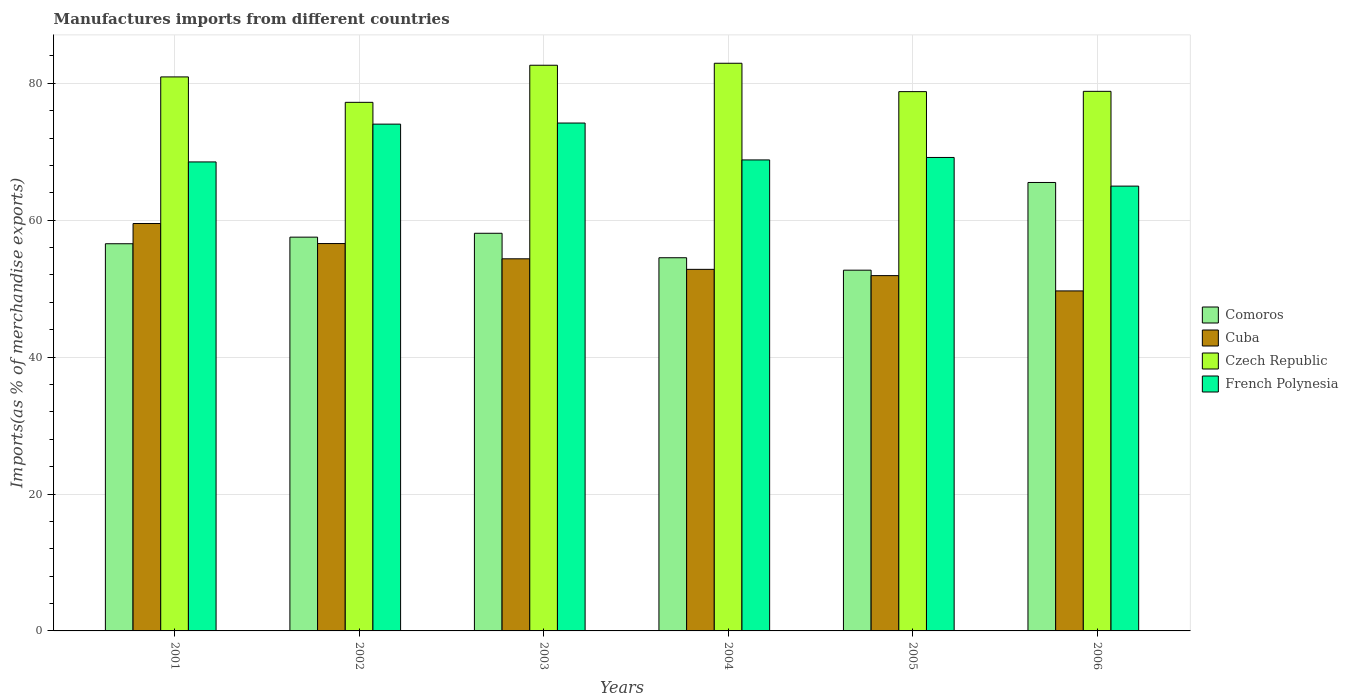How many bars are there on the 5th tick from the right?
Give a very brief answer. 4. What is the label of the 3rd group of bars from the left?
Give a very brief answer. 2003. In how many cases, is the number of bars for a given year not equal to the number of legend labels?
Offer a terse response. 0. What is the percentage of imports to different countries in Comoros in 2003?
Give a very brief answer. 58.09. Across all years, what is the maximum percentage of imports to different countries in Czech Republic?
Make the answer very short. 82.93. Across all years, what is the minimum percentage of imports to different countries in French Polynesia?
Your answer should be compact. 64.98. What is the total percentage of imports to different countries in Comoros in the graph?
Your answer should be compact. 344.9. What is the difference between the percentage of imports to different countries in Czech Republic in 2003 and that in 2004?
Make the answer very short. -0.29. What is the difference between the percentage of imports to different countries in Cuba in 2002 and the percentage of imports to different countries in Czech Republic in 2004?
Give a very brief answer. -26.34. What is the average percentage of imports to different countries in Comoros per year?
Your answer should be very brief. 57.48. In the year 2004, what is the difference between the percentage of imports to different countries in Czech Republic and percentage of imports to different countries in Comoros?
Your response must be concise. 28.41. What is the ratio of the percentage of imports to different countries in Czech Republic in 2002 to that in 2005?
Offer a terse response. 0.98. Is the difference between the percentage of imports to different countries in Czech Republic in 2001 and 2006 greater than the difference between the percentage of imports to different countries in Comoros in 2001 and 2006?
Your answer should be very brief. Yes. What is the difference between the highest and the second highest percentage of imports to different countries in Czech Republic?
Offer a very short reply. 0.29. What is the difference between the highest and the lowest percentage of imports to different countries in Czech Republic?
Offer a terse response. 5.71. In how many years, is the percentage of imports to different countries in Czech Republic greater than the average percentage of imports to different countries in Czech Republic taken over all years?
Offer a very short reply. 3. Is it the case that in every year, the sum of the percentage of imports to different countries in Comoros and percentage of imports to different countries in Cuba is greater than the sum of percentage of imports to different countries in Czech Republic and percentage of imports to different countries in French Polynesia?
Provide a short and direct response. No. What does the 4th bar from the left in 2003 represents?
Provide a succinct answer. French Polynesia. What does the 2nd bar from the right in 2006 represents?
Give a very brief answer. Czech Republic. How many bars are there?
Give a very brief answer. 24. What is the difference between two consecutive major ticks on the Y-axis?
Your answer should be very brief. 20. Are the values on the major ticks of Y-axis written in scientific E-notation?
Provide a short and direct response. No. Does the graph contain grids?
Ensure brevity in your answer.  Yes. How many legend labels are there?
Your response must be concise. 4. What is the title of the graph?
Your answer should be very brief. Manufactures imports from different countries. Does "Mexico" appear as one of the legend labels in the graph?
Offer a terse response. No. What is the label or title of the X-axis?
Ensure brevity in your answer.  Years. What is the label or title of the Y-axis?
Ensure brevity in your answer.  Imports(as % of merchandise exports). What is the Imports(as % of merchandise exports) in Comoros in 2001?
Your answer should be very brief. 56.56. What is the Imports(as % of merchandise exports) in Cuba in 2001?
Give a very brief answer. 59.51. What is the Imports(as % of merchandise exports) in Czech Republic in 2001?
Provide a succinct answer. 80.93. What is the Imports(as % of merchandise exports) in French Polynesia in 2001?
Provide a short and direct response. 68.51. What is the Imports(as % of merchandise exports) of Comoros in 2002?
Your answer should be very brief. 57.52. What is the Imports(as % of merchandise exports) of Cuba in 2002?
Provide a succinct answer. 56.59. What is the Imports(as % of merchandise exports) of Czech Republic in 2002?
Offer a very short reply. 77.22. What is the Imports(as % of merchandise exports) in French Polynesia in 2002?
Make the answer very short. 74.03. What is the Imports(as % of merchandise exports) in Comoros in 2003?
Offer a terse response. 58.09. What is the Imports(as % of merchandise exports) of Cuba in 2003?
Make the answer very short. 54.36. What is the Imports(as % of merchandise exports) in Czech Republic in 2003?
Make the answer very short. 82.64. What is the Imports(as % of merchandise exports) in French Polynesia in 2003?
Your answer should be very brief. 74.19. What is the Imports(as % of merchandise exports) in Comoros in 2004?
Your response must be concise. 54.52. What is the Imports(as % of merchandise exports) in Cuba in 2004?
Offer a very short reply. 52.82. What is the Imports(as % of merchandise exports) of Czech Republic in 2004?
Give a very brief answer. 82.93. What is the Imports(as % of merchandise exports) in French Polynesia in 2004?
Keep it short and to the point. 68.8. What is the Imports(as % of merchandise exports) of Comoros in 2005?
Ensure brevity in your answer.  52.7. What is the Imports(as % of merchandise exports) in Cuba in 2005?
Your answer should be very brief. 51.9. What is the Imports(as % of merchandise exports) in Czech Republic in 2005?
Your answer should be compact. 78.78. What is the Imports(as % of merchandise exports) of French Polynesia in 2005?
Your answer should be compact. 69.17. What is the Imports(as % of merchandise exports) in Comoros in 2006?
Keep it short and to the point. 65.51. What is the Imports(as % of merchandise exports) of Cuba in 2006?
Give a very brief answer. 49.67. What is the Imports(as % of merchandise exports) of Czech Republic in 2006?
Your answer should be compact. 78.82. What is the Imports(as % of merchandise exports) of French Polynesia in 2006?
Your answer should be compact. 64.98. Across all years, what is the maximum Imports(as % of merchandise exports) in Comoros?
Offer a terse response. 65.51. Across all years, what is the maximum Imports(as % of merchandise exports) in Cuba?
Your response must be concise. 59.51. Across all years, what is the maximum Imports(as % of merchandise exports) of Czech Republic?
Give a very brief answer. 82.93. Across all years, what is the maximum Imports(as % of merchandise exports) of French Polynesia?
Your answer should be compact. 74.19. Across all years, what is the minimum Imports(as % of merchandise exports) in Comoros?
Keep it short and to the point. 52.7. Across all years, what is the minimum Imports(as % of merchandise exports) of Cuba?
Make the answer very short. 49.67. Across all years, what is the minimum Imports(as % of merchandise exports) in Czech Republic?
Your answer should be compact. 77.22. Across all years, what is the minimum Imports(as % of merchandise exports) in French Polynesia?
Your answer should be very brief. 64.98. What is the total Imports(as % of merchandise exports) of Comoros in the graph?
Your answer should be very brief. 344.9. What is the total Imports(as % of merchandise exports) of Cuba in the graph?
Give a very brief answer. 324.86. What is the total Imports(as % of merchandise exports) of Czech Republic in the graph?
Offer a very short reply. 481.32. What is the total Imports(as % of merchandise exports) in French Polynesia in the graph?
Your response must be concise. 419.69. What is the difference between the Imports(as % of merchandise exports) of Comoros in 2001 and that in 2002?
Make the answer very short. -0.96. What is the difference between the Imports(as % of merchandise exports) in Cuba in 2001 and that in 2002?
Offer a very short reply. 2.93. What is the difference between the Imports(as % of merchandise exports) of Czech Republic in 2001 and that in 2002?
Your answer should be compact. 3.71. What is the difference between the Imports(as % of merchandise exports) of French Polynesia in 2001 and that in 2002?
Keep it short and to the point. -5.52. What is the difference between the Imports(as % of merchandise exports) in Comoros in 2001 and that in 2003?
Your answer should be very brief. -1.53. What is the difference between the Imports(as % of merchandise exports) in Cuba in 2001 and that in 2003?
Keep it short and to the point. 5.15. What is the difference between the Imports(as % of merchandise exports) in Czech Republic in 2001 and that in 2003?
Your response must be concise. -1.71. What is the difference between the Imports(as % of merchandise exports) in French Polynesia in 2001 and that in 2003?
Provide a short and direct response. -5.68. What is the difference between the Imports(as % of merchandise exports) of Comoros in 2001 and that in 2004?
Your response must be concise. 2.05. What is the difference between the Imports(as % of merchandise exports) in Cuba in 2001 and that in 2004?
Your response must be concise. 6.69. What is the difference between the Imports(as % of merchandise exports) of Czech Republic in 2001 and that in 2004?
Give a very brief answer. -1.99. What is the difference between the Imports(as % of merchandise exports) in French Polynesia in 2001 and that in 2004?
Give a very brief answer. -0.29. What is the difference between the Imports(as % of merchandise exports) in Comoros in 2001 and that in 2005?
Provide a succinct answer. 3.86. What is the difference between the Imports(as % of merchandise exports) in Cuba in 2001 and that in 2005?
Ensure brevity in your answer.  7.61. What is the difference between the Imports(as % of merchandise exports) in Czech Republic in 2001 and that in 2005?
Keep it short and to the point. 2.15. What is the difference between the Imports(as % of merchandise exports) of French Polynesia in 2001 and that in 2005?
Give a very brief answer. -0.65. What is the difference between the Imports(as % of merchandise exports) of Comoros in 2001 and that in 2006?
Your response must be concise. -8.95. What is the difference between the Imports(as % of merchandise exports) of Cuba in 2001 and that in 2006?
Keep it short and to the point. 9.84. What is the difference between the Imports(as % of merchandise exports) in Czech Republic in 2001 and that in 2006?
Offer a terse response. 2.11. What is the difference between the Imports(as % of merchandise exports) of French Polynesia in 2001 and that in 2006?
Ensure brevity in your answer.  3.53. What is the difference between the Imports(as % of merchandise exports) of Comoros in 2002 and that in 2003?
Keep it short and to the point. -0.56. What is the difference between the Imports(as % of merchandise exports) in Cuba in 2002 and that in 2003?
Offer a terse response. 2.23. What is the difference between the Imports(as % of merchandise exports) in Czech Republic in 2002 and that in 2003?
Ensure brevity in your answer.  -5.42. What is the difference between the Imports(as % of merchandise exports) of French Polynesia in 2002 and that in 2003?
Ensure brevity in your answer.  -0.16. What is the difference between the Imports(as % of merchandise exports) in Comoros in 2002 and that in 2004?
Ensure brevity in your answer.  3.01. What is the difference between the Imports(as % of merchandise exports) in Cuba in 2002 and that in 2004?
Make the answer very short. 3.77. What is the difference between the Imports(as % of merchandise exports) of Czech Republic in 2002 and that in 2004?
Provide a short and direct response. -5.71. What is the difference between the Imports(as % of merchandise exports) in French Polynesia in 2002 and that in 2004?
Your answer should be very brief. 5.23. What is the difference between the Imports(as % of merchandise exports) of Comoros in 2002 and that in 2005?
Offer a terse response. 4.83. What is the difference between the Imports(as % of merchandise exports) in Cuba in 2002 and that in 2005?
Keep it short and to the point. 4.68. What is the difference between the Imports(as % of merchandise exports) of Czech Republic in 2002 and that in 2005?
Your response must be concise. -1.56. What is the difference between the Imports(as % of merchandise exports) of French Polynesia in 2002 and that in 2005?
Ensure brevity in your answer.  4.87. What is the difference between the Imports(as % of merchandise exports) in Comoros in 2002 and that in 2006?
Your answer should be very brief. -7.99. What is the difference between the Imports(as % of merchandise exports) of Cuba in 2002 and that in 2006?
Your answer should be very brief. 6.92. What is the difference between the Imports(as % of merchandise exports) of Czech Republic in 2002 and that in 2006?
Make the answer very short. -1.61. What is the difference between the Imports(as % of merchandise exports) of French Polynesia in 2002 and that in 2006?
Keep it short and to the point. 9.06. What is the difference between the Imports(as % of merchandise exports) of Comoros in 2003 and that in 2004?
Keep it short and to the point. 3.57. What is the difference between the Imports(as % of merchandise exports) in Cuba in 2003 and that in 2004?
Make the answer very short. 1.54. What is the difference between the Imports(as % of merchandise exports) of Czech Republic in 2003 and that in 2004?
Ensure brevity in your answer.  -0.29. What is the difference between the Imports(as % of merchandise exports) of French Polynesia in 2003 and that in 2004?
Provide a short and direct response. 5.39. What is the difference between the Imports(as % of merchandise exports) in Comoros in 2003 and that in 2005?
Provide a succinct answer. 5.39. What is the difference between the Imports(as % of merchandise exports) in Cuba in 2003 and that in 2005?
Provide a succinct answer. 2.46. What is the difference between the Imports(as % of merchandise exports) in Czech Republic in 2003 and that in 2005?
Keep it short and to the point. 3.86. What is the difference between the Imports(as % of merchandise exports) in French Polynesia in 2003 and that in 2005?
Keep it short and to the point. 5.03. What is the difference between the Imports(as % of merchandise exports) in Comoros in 2003 and that in 2006?
Provide a short and direct response. -7.42. What is the difference between the Imports(as % of merchandise exports) of Cuba in 2003 and that in 2006?
Offer a terse response. 4.69. What is the difference between the Imports(as % of merchandise exports) in Czech Republic in 2003 and that in 2006?
Ensure brevity in your answer.  3.81. What is the difference between the Imports(as % of merchandise exports) of French Polynesia in 2003 and that in 2006?
Ensure brevity in your answer.  9.21. What is the difference between the Imports(as % of merchandise exports) of Comoros in 2004 and that in 2005?
Your answer should be compact. 1.82. What is the difference between the Imports(as % of merchandise exports) of Cuba in 2004 and that in 2005?
Ensure brevity in your answer.  0.92. What is the difference between the Imports(as % of merchandise exports) of Czech Republic in 2004 and that in 2005?
Your answer should be compact. 4.14. What is the difference between the Imports(as % of merchandise exports) in French Polynesia in 2004 and that in 2005?
Your answer should be very brief. -0.36. What is the difference between the Imports(as % of merchandise exports) in Comoros in 2004 and that in 2006?
Your answer should be very brief. -10.99. What is the difference between the Imports(as % of merchandise exports) in Cuba in 2004 and that in 2006?
Ensure brevity in your answer.  3.15. What is the difference between the Imports(as % of merchandise exports) of Czech Republic in 2004 and that in 2006?
Your answer should be compact. 4.1. What is the difference between the Imports(as % of merchandise exports) in French Polynesia in 2004 and that in 2006?
Keep it short and to the point. 3.83. What is the difference between the Imports(as % of merchandise exports) of Comoros in 2005 and that in 2006?
Keep it short and to the point. -12.81. What is the difference between the Imports(as % of merchandise exports) of Cuba in 2005 and that in 2006?
Offer a terse response. 2.23. What is the difference between the Imports(as % of merchandise exports) of Czech Republic in 2005 and that in 2006?
Give a very brief answer. -0.04. What is the difference between the Imports(as % of merchandise exports) of French Polynesia in 2005 and that in 2006?
Provide a succinct answer. 4.19. What is the difference between the Imports(as % of merchandise exports) in Comoros in 2001 and the Imports(as % of merchandise exports) in Cuba in 2002?
Your answer should be compact. -0.03. What is the difference between the Imports(as % of merchandise exports) of Comoros in 2001 and the Imports(as % of merchandise exports) of Czech Republic in 2002?
Offer a terse response. -20.66. What is the difference between the Imports(as % of merchandise exports) of Comoros in 2001 and the Imports(as % of merchandise exports) of French Polynesia in 2002?
Offer a terse response. -17.47. What is the difference between the Imports(as % of merchandise exports) in Cuba in 2001 and the Imports(as % of merchandise exports) in Czech Republic in 2002?
Ensure brevity in your answer.  -17.7. What is the difference between the Imports(as % of merchandise exports) in Cuba in 2001 and the Imports(as % of merchandise exports) in French Polynesia in 2002?
Give a very brief answer. -14.52. What is the difference between the Imports(as % of merchandise exports) of Czech Republic in 2001 and the Imports(as % of merchandise exports) of French Polynesia in 2002?
Offer a terse response. 6.9. What is the difference between the Imports(as % of merchandise exports) in Comoros in 2001 and the Imports(as % of merchandise exports) in Cuba in 2003?
Offer a very short reply. 2.2. What is the difference between the Imports(as % of merchandise exports) of Comoros in 2001 and the Imports(as % of merchandise exports) of Czech Republic in 2003?
Provide a succinct answer. -26.08. What is the difference between the Imports(as % of merchandise exports) in Comoros in 2001 and the Imports(as % of merchandise exports) in French Polynesia in 2003?
Ensure brevity in your answer.  -17.63. What is the difference between the Imports(as % of merchandise exports) in Cuba in 2001 and the Imports(as % of merchandise exports) in Czech Republic in 2003?
Ensure brevity in your answer.  -23.12. What is the difference between the Imports(as % of merchandise exports) in Cuba in 2001 and the Imports(as % of merchandise exports) in French Polynesia in 2003?
Your answer should be very brief. -14.68. What is the difference between the Imports(as % of merchandise exports) of Czech Republic in 2001 and the Imports(as % of merchandise exports) of French Polynesia in 2003?
Provide a short and direct response. 6.74. What is the difference between the Imports(as % of merchandise exports) in Comoros in 2001 and the Imports(as % of merchandise exports) in Cuba in 2004?
Offer a terse response. 3.74. What is the difference between the Imports(as % of merchandise exports) in Comoros in 2001 and the Imports(as % of merchandise exports) in Czech Republic in 2004?
Give a very brief answer. -26.37. What is the difference between the Imports(as % of merchandise exports) in Comoros in 2001 and the Imports(as % of merchandise exports) in French Polynesia in 2004?
Make the answer very short. -12.24. What is the difference between the Imports(as % of merchandise exports) in Cuba in 2001 and the Imports(as % of merchandise exports) in Czech Republic in 2004?
Make the answer very short. -23.41. What is the difference between the Imports(as % of merchandise exports) of Cuba in 2001 and the Imports(as % of merchandise exports) of French Polynesia in 2004?
Ensure brevity in your answer.  -9.29. What is the difference between the Imports(as % of merchandise exports) of Czech Republic in 2001 and the Imports(as % of merchandise exports) of French Polynesia in 2004?
Your answer should be compact. 12.13. What is the difference between the Imports(as % of merchandise exports) in Comoros in 2001 and the Imports(as % of merchandise exports) in Cuba in 2005?
Provide a short and direct response. 4.66. What is the difference between the Imports(as % of merchandise exports) in Comoros in 2001 and the Imports(as % of merchandise exports) in Czech Republic in 2005?
Your response must be concise. -22.22. What is the difference between the Imports(as % of merchandise exports) in Comoros in 2001 and the Imports(as % of merchandise exports) in French Polynesia in 2005?
Offer a very short reply. -12.61. What is the difference between the Imports(as % of merchandise exports) in Cuba in 2001 and the Imports(as % of merchandise exports) in Czech Republic in 2005?
Offer a very short reply. -19.27. What is the difference between the Imports(as % of merchandise exports) in Cuba in 2001 and the Imports(as % of merchandise exports) in French Polynesia in 2005?
Your answer should be very brief. -9.65. What is the difference between the Imports(as % of merchandise exports) of Czech Republic in 2001 and the Imports(as % of merchandise exports) of French Polynesia in 2005?
Your answer should be compact. 11.77. What is the difference between the Imports(as % of merchandise exports) of Comoros in 2001 and the Imports(as % of merchandise exports) of Cuba in 2006?
Offer a terse response. 6.89. What is the difference between the Imports(as % of merchandise exports) in Comoros in 2001 and the Imports(as % of merchandise exports) in Czech Republic in 2006?
Provide a short and direct response. -22.26. What is the difference between the Imports(as % of merchandise exports) of Comoros in 2001 and the Imports(as % of merchandise exports) of French Polynesia in 2006?
Keep it short and to the point. -8.42. What is the difference between the Imports(as % of merchandise exports) in Cuba in 2001 and the Imports(as % of merchandise exports) in Czech Republic in 2006?
Keep it short and to the point. -19.31. What is the difference between the Imports(as % of merchandise exports) in Cuba in 2001 and the Imports(as % of merchandise exports) in French Polynesia in 2006?
Make the answer very short. -5.46. What is the difference between the Imports(as % of merchandise exports) of Czech Republic in 2001 and the Imports(as % of merchandise exports) of French Polynesia in 2006?
Provide a succinct answer. 15.95. What is the difference between the Imports(as % of merchandise exports) of Comoros in 2002 and the Imports(as % of merchandise exports) of Cuba in 2003?
Your answer should be compact. 3.16. What is the difference between the Imports(as % of merchandise exports) in Comoros in 2002 and the Imports(as % of merchandise exports) in Czech Republic in 2003?
Provide a short and direct response. -25.11. What is the difference between the Imports(as % of merchandise exports) in Comoros in 2002 and the Imports(as % of merchandise exports) in French Polynesia in 2003?
Keep it short and to the point. -16.67. What is the difference between the Imports(as % of merchandise exports) in Cuba in 2002 and the Imports(as % of merchandise exports) in Czech Republic in 2003?
Offer a terse response. -26.05. What is the difference between the Imports(as % of merchandise exports) of Cuba in 2002 and the Imports(as % of merchandise exports) of French Polynesia in 2003?
Make the answer very short. -17.6. What is the difference between the Imports(as % of merchandise exports) of Czech Republic in 2002 and the Imports(as % of merchandise exports) of French Polynesia in 2003?
Provide a succinct answer. 3.02. What is the difference between the Imports(as % of merchandise exports) in Comoros in 2002 and the Imports(as % of merchandise exports) in Cuba in 2004?
Offer a very short reply. 4.7. What is the difference between the Imports(as % of merchandise exports) of Comoros in 2002 and the Imports(as % of merchandise exports) of Czech Republic in 2004?
Provide a succinct answer. -25.4. What is the difference between the Imports(as % of merchandise exports) of Comoros in 2002 and the Imports(as % of merchandise exports) of French Polynesia in 2004?
Provide a succinct answer. -11.28. What is the difference between the Imports(as % of merchandise exports) of Cuba in 2002 and the Imports(as % of merchandise exports) of Czech Republic in 2004?
Ensure brevity in your answer.  -26.34. What is the difference between the Imports(as % of merchandise exports) in Cuba in 2002 and the Imports(as % of merchandise exports) in French Polynesia in 2004?
Provide a succinct answer. -12.22. What is the difference between the Imports(as % of merchandise exports) in Czech Republic in 2002 and the Imports(as % of merchandise exports) in French Polynesia in 2004?
Offer a terse response. 8.41. What is the difference between the Imports(as % of merchandise exports) in Comoros in 2002 and the Imports(as % of merchandise exports) in Cuba in 2005?
Offer a terse response. 5.62. What is the difference between the Imports(as % of merchandise exports) in Comoros in 2002 and the Imports(as % of merchandise exports) in Czech Republic in 2005?
Give a very brief answer. -21.26. What is the difference between the Imports(as % of merchandise exports) of Comoros in 2002 and the Imports(as % of merchandise exports) of French Polynesia in 2005?
Make the answer very short. -11.64. What is the difference between the Imports(as % of merchandise exports) in Cuba in 2002 and the Imports(as % of merchandise exports) in Czech Republic in 2005?
Make the answer very short. -22.19. What is the difference between the Imports(as % of merchandise exports) in Cuba in 2002 and the Imports(as % of merchandise exports) in French Polynesia in 2005?
Your answer should be compact. -12.58. What is the difference between the Imports(as % of merchandise exports) in Czech Republic in 2002 and the Imports(as % of merchandise exports) in French Polynesia in 2005?
Make the answer very short. 8.05. What is the difference between the Imports(as % of merchandise exports) in Comoros in 2002 and the Imports(as % of merchandise exports) in Cuba in 2006?
Ensure brevity in your answer.  7.85. What is the difference between the Imports(as % of merchandise exports) of Comoros in 2002 and the Imports(as % of merchandise exports) of Czech Republic in 2006?
Your answer should be compact. -21.3. What is the difference between the Imports(as % of merchandise exports) of Comoros in 2002 and the Imports(as % of merchandise exports) of French Polynesia in 2006?
Your answer should be compact. -7.45. What is the difference between the Imports(as % of merchandise exports) in Cuba in 2002 and the Imports(as % of merchandise exports) in Czech Republic in 2006?
Your response must be concise. -22.24. What is the difference between the Imports(as % of merchandise exports) in Cuba in 2002 and the Imports(as % of merchandise exports) in French Polynesia in 2006?
Your response must be concise. -8.39. What is the difference between the Imports(as % of merchandise exports) in Czech Republic in 2002 and the Imports(as % of merchandise exports) in French Polynesia in 2006?
Your answer should be compact. 12.24. What is the difference between the Imports(as % of merchandise exports) of Comoros in 2003 and the Imports(as % of merchandise exports) of Cuba in 2004?
Keep it short and to the point. 5.27. What is the difference between the Imports(as % of merchandise exports) of Comoros in 2003 and the Imports(as % of merchandise exports) of Czech Republic in 2004?
Provide a short and direct response. -24.84. What is the difference between the Imports(as % of merchandise exports) in Comoros in 2003 and the Imports(as % of merchandise exports) in French Polynesia in 2004?
Your answer should be very brief. -10.72. What is the difference between the Imports(as % of merchandise exports) in Cuba in 2003 and the Imports(as % of merchandise exports) in Czech Republic in 2004?
Give a very brief answer. -28.57. What is the difference between the Imports(as % of merchandise exports) of Cuba in 2003 and the Imports(as % of merchandise exports) of French Polynesia in 2004?
Provide a short and direct response. -14.44. What is the difference between the Imports(as % of merchandise exports) of Czech Republic in 2003 and the Imports(as % of merchandise exports) of French Polynesia in 2004?
Make the answer very short. 13.83. What is the difference between the Imports(as % of merchandise exports) of Comoros in 2003 and the Imports(as % of merchandise exports) of Cuba in 2005?
Offer a very short reply. 6.18. What is the difference between the Imports(as % of merchandise exports) in Comoros in 2003 and the Imports(as % of merchandise exports) in Czech Republic in 2005?
Make the answer very short. -20.69. What is the difference between the Imports(as % of merchandise exports) in Comoros in 2003 and the Imports(as % of merchandise exports) in French Polynesia in 2005?
Provide a short and direct response. -11.08. What is the difference between the Imports(as % of merchandise exports) of Cuba in 2003 and the Imports(as % of merchandise exports) of Czech Republic in 2005?
Make the answer very short. -24.42. What is the difference between the Imports(as % of merchandise exports) of Cuba in 2003 and the Imports(as % of merchandise exports) of French Polynesia in 2005?
Your answer should be very brief. -14.81. What is the difference between the Imports(as % of merchandise exports) of Czech Republic in 2003 and the Imports(as % of merchandise exports) of French Polynesia in 2005?
Your answer should be compact. 13.47. What is the difference between the Imports(as % of merchandise exports) in Comoros in 2003 and the Imports(as % of merchandise exports) in Cuba in 2006?
Provide a short and direct response. 8.42. What is the difference between the Imports(as % of merchandise exports) in Comoros in 2003 and the Imports(as % of merchandise exports) in Czech Republic in 2006?
Give a very brief answer. -20.73. What is the difference between the Imports(as % of merchandise exports) in Comoros in 2003 and the Imports(as % of merchandise exports) in French Polynesia in 2006?
Your answer should be compact. -6.89. What is the difference between the Imports(as % of merchandise exports) of Cuba in 2003 and the Imports(as % of merchandise exports) of Czech Republic in 2006?
Offer a very short reply. -24.46. What is the difference between the Imports(as % of merchandise exports) in Cuba in 2003 and the Imports(as % of merchandise exports) in French Polynesia in 2006?
Offer a very short reply. -10.62. What is the difference between the Imports(as % of merchandise exports) in Czech Republic in 2003 and the Imports(as % of merchandise exports) in French Polynesia in 2006?
Make the answer very short. 17.66. What is the difference between the Imports(as % of merchandise exports) of Comoros in 2004 and the Imports(as % of merchandise exports) of Cuba in 2005?
Offer a very short reply. 2.61. What is the difference between the Imports(as % of merchandise exports) of Comoros in 2004 and the Imports(as % of merchandise exports) of Czech Republic in 2005?
Make the answer very short. -24.27. What is the difference between the Imports(as % of merchandise exports) of Comoros in 2004 and the Imports(as % of merchandise exports) of French Polynesia in 2005?
Your answer should be compact. -14.65. What is the difference between the Imports(as % of merchandise exports) of Cuba in 2004 and the Imports(as % of merchandise exports) of Czech Republic in 2005?
Your answer should be compact. -25.96. What is the difference between the Imports(as % of merchandise exports) in Cuba in 2004 and the Imports(as % of merchandise exports) in French Polynesia in 2005?
Keep it short and to the point. -16.35. What is the difference between the Imports(as % of merchandise exports) in Czech Republic in 2004 and the Imports(as % of merchandise exports) in French Polynesia in 2005?
Offer a terse response. 13.76. What is the difference between the Imports(as % of merchandise exports) of Comoros in 2004 and the Imports(as % of merchandise exports) of Cuba in 2006?
Offer a very short reply. 4.84. What is the difference between the Imports(as % of merchandise exports) in Comoros in 2004 and the Imports(as % of merchandise exports) in Czech Republic in 2006?
Your answer should be compact. -24.31. What is the difference between the Imports(as % of merchandise exports) in Comoros in 2004 and the Imports(as % of merchandise exports) in French Polynesia in 2006?
Give a very brief answer. -10.46. What is the difference between the Imports(as % of merchandise exports) in Cuba in 2004 and the Imports(as % of merchandise exports) in Czech Republic in 2006?
Keep it short and to the point. -26. What is the difference between the Imports(as % of merchandise exports) in Cuba in 2004 and the Imports(as % of merchandise exports) in French Polynesia in 2006?
Provide a succinct answer. -12.16. What is the difference between the Imports(as % of merchandise exports) of Czech Republic in 2004 and the Imports(as % of merchandise exports) of French Polynesia in 2006?
Offer a terse response. 17.95. What is the difference between the Imports(as % of merchandise exports) in Comoros in 2005 and the Imports(as % of merchandise exports) in Cuba in 2006?
Offer a very short reply. 3.03. What is the difference between the Imports(as % of merchandise exports) of Comoros in 2005 and the Imports(as % of merchandise exports) of Czech Republic in 2006?
Make the answer very short. -26.12. What is the difference between the Imports(as % of merchandise exports) of Comoros in 2005 and the Imports(as % of merchandise exports) of French Polynesia in 2006?
Your answer should be compact. -12.28. What is the difference between the Imports(as % of merchandise exports) of Cuba in 2005 and the Imports(as % of merchandise exports) of Czech Republic in 2006?
Give a very brief answer. -26.92. What is the difference between the Imports(as % of merchandise exports) of Cuba in 2005 and the Imports(as % of merchandise exports) of French Polynesia in 2006?
Ensure brevity in your answer.  -13.07. What is the difference between the Imports(as % of merchandise exports) in Czech Republic in 2005 and the Imports(as % of merchandise exports) in French Polynesia in 2006?
Provide a succinct answer. 13.8. What is the average Imports(as % of merchandise exports) of Comoros per year?
Provide a succinct answer. 57.48. What is the average Imports(as % of merchandise exports) in Cuba per year?
Your response must be concise. 54.14. What is the average Imports(as % of merchandise exports) in Czech Republic per year?
Keep it short and to the point. 80.22. What is the average Imports(as % of merchandise exports) in French Polynesia per year?
Make the answer very short. 69.95. In the year 2001, what is the difference between the Imports(as % of merchandise exports) of Comoros and Imports(as % of merchandise exports) of Cuba?
Make the answer very short. -2.95. In the year 2001, what is the difference between the Imports(as % of merchandise exports) of Comoros and Imports(as % of merchandise exports) of Czech Republic?
Offer a terse response. -24.37. In the year 2001, what is the difference between the Imports(as % of merchandise exports) of Comoros and Imports(as % of merchandise exports) of French Polynesia?
Provide a succinct answer. -11.95. In the year 2001, what is the difference between the Imports(as % of merchandise exports) of Cuba and Imports(as % of merchandise exports) of Czech Republic?
Ensure brevity in your answer.  -21.42. In the year 2001, what is the difference between the Imports(as % of merchandise exports) in Cuba and Imports(as % of merchandise exports) in French Polynesia?
Keep it short and to the point. -9. In the year 2001, what is the difference between the Imports(as % of merchandise exports) in Czech Republic and Imports(as % of merchandise exports) in French Polynesia?
Provide a succinct answer. 12.42. In the year 2002, what is the difference between the Imports(as % of merchandise exports) in Comoros and Imports(as % of merchandise exports) in Cuba?
Keep it short and to the point. 0.94. In the year 2002, what is the difference between the Imports(as % of merchandise exports) in Comoros and Imports(as % of merchandise exports) in Czech Republic?
Provide a succinct answer. -19.69. In the year 2002, what is the difference between the Imports(as % of merchandise exports) in Comoros and Imports(as % of merchandise exports) in French Polynesia?
Your answer should be compact. -16.51. In the year 2002, what is the difference between the Imports(as % of merchandise exports) in Cuba and Imports(as % of merchandise exports) in Czech Republic?
Offer a very short reply. -20.63. In the year 2002, what is the difference between the Imports(as % of merchandise exports) of Cuba and Imports(as % of merchandise exports) of French Polynesia?
Your response must be concise. -17.45. In the year 2002, what is the difference between the Imports(as % of merchandise exports) in Czech Republic and Imports(as % of merchandise exports) in French Polynesia?
Keep it short and to the point. 3.18. In the year 2003, what is the difference between the Imports(as % of merchandise exports) in Comoros and Imports(as % of merchandise exports) in Cuba?
Make the answer very short. 3.73. In the year 2003, what is the difference between the Imports(as % of merchandise exports) in Comoros and Imports(as % of merchandise exports) in Czech Republic?
Offer a terse response. -24.55. In the year 2003, what is the difference between the Imports(as % of merchandise exports) of Comoros and Imports(as % of merchandise exports) of French Polynesia?
Offer a very short reply. -16.1. In the year 2003, what is the difference between the Imports(as % of merchandise exports) in Cuba and Imports(as % of merchandise exports) in Czech Republic?
Your answer should be compact. -28.28. In the year 2003, what is the difference between the Imports(as % of merchandise exports) in Cuba and Imports(as % of merchandise exports) in French Polynesia?
Offer a terse response. -19.83. In the year 2003, what is the difference between the Imports(as % of merchandise exports) in Czech Republic and Imports(as % of merchandise exports) in French Polynesia?
Offer a very short reply. 8.44. In the year 2004, what is the difference between the Imports(as % of merchandise exports) in Comoros and Imports(as % of merchandise exports) in Cuba?
Offer a terse response. 1.7. In the year 2004, what is the difference between the Imports(as % of merchandise exports) in Comoros and Imports(as % of merchandise exports) in Czech Republic?
Ensure brevity in your answer.  -28.41. In the year 2004, what is the difference between the Imports(as % of merchandise exports) in Comoros and Imports(as % of merchandise exports) in French Polynesia?
Provide a short and direct response. -14.29. In the year 2004, what is the difference between the Imports(as % of merchandise exports) in Cuba and Imports(as % of merchandise exports) in Czech Republic?
Your answer should be very brief. -30.11. In the year 2004, what is the difference between the Imports(as % of merchandise exports) of Cuba and Imports(as % of merchandise exports) of French Polynesia?
Provide a succinct answer. -15.98. In the year 2004, what is the difference between the Imports(as % of merchandise exports) in Czech Republic and Imports(as % of merchandise exports) in French Polynesia?
Give a very brief answer. 14.12. In the year 2005, what is the difference between the Imports(as % of merchandise exports) in Comoros and Imports(as % of merchandise exports) in Cuba?
Provide a short and direct response. 0.79. In the year 2005, what is the difference between the Imports(as % of merchandise exports) in Comoros and Imports(as % of merchandise exports) in Czech Republic?
Offer a terse response. -26.08. In the year 2005, what is the difference between the Imports(as % of merchandise exports) of Comoros and Imports(as % of merchandise exports) of French Polynesia?
Keep it short and to the point. -16.47. In the year 2005, what is the difference between the Imports(as % of merchandise exports) in Cuba and Imports(as % of merchandise exports) in Czech Republic?
Provide a succinct answer. -26.88. In the year 2005, what is the difference between the Imports(as % of merchandise exports) in Cuba and Imports(as % of merchandise exports) in French Polynesia?
Keep it short and to the point. -17.26. In the year 2005, what is the difference between the Imports(as % of merchandise exports) in Czech Republic and Imports(as % of merchandise exports) in French Polynesia?
Your response must be concise. 9.62. In the year 2006, what is the difference between the Imports(as % of merchandise exports) of Comoros and Imports(as % of merchandise exports) of Cuba?
Provide a short and direct response. 15.84. In the year 2006, what is the difference between the Imports(as % of merchandise exports) of Comoros and Imports(as % of merchandise exports) of Czech Republic?
Give a very brief answer. -13.31. In the year 2006, what is the difference between the Imports(as % of merchandise exports) of Comoros and Imports(as % of merchandise exports) of French Polynesia?
Offer a terse response. 0.53. In the year 2006, what is the difference between the Imports(as % of merchandise exports) in Cuba and Imports(as % of merchandise exports) in Czech Republic?
Keep it short and to the point. -29.15. In the year 2006, what is the difference between the Imports(as % of merchandise exports) in Cuba and Imports(as % of merchandise exports) in French Polynesia?
Your answer should be very brief. -15.31. In the year 2006, what is the difference between the Imports(as % of merchandise exports) in Czech Republic and Imports(as % of merchandise exports) in French Polynesia?
Your response must be concise. 13.85. What is the ratio of the Imports(as % of merchandise exports) in Comoros in 2001 to that in 2002?
Offer a terse response. 0.98. What is the ratio of the Imports(as % of merchandise exports) in Cuba in 2001 to that in 2002?
Keep it short and to the point. 1.05. What is the ratio of the Imports(as % of merchandise exports) in Czech Republic in 2001 to that in 2002?
Keep it short and to the point. 1.05. What is the ratio of the Imports(as % of merchandise exports) in French Polynesia in 2001 to that in 2002?
Offer a very short reply. 0.93. What is the ratio of the Imports(as % of merchandise exports) of Comoros in 2001 to that in 2003?
Your answer should be compact. 0.97. What is the ratio of the Imports(as % of merchandise exports) of Cuba in 2001 to that in 2003?
Provide a succinct answer. 1.09. What is the ratio of the Imports(as % of merchandise exports) of Czech Republic in 2001 to that in 2003?
Your answer should be compact. 0.98. What is the ratio of the Imports(as % of merchandise exports) of French Polynesia in 2001 to that in 2003?
Ensure brevity in your answer.  0.92. What is the ratio of the Imports(as % of merchandise exports) of Comoros in 2001 to that in 2004?
Offer a very short reply. 1.04. What is the ratio of the Imports(as % of merchandise exports) in Cuba in 2001 to that in 2004?
Offer a terse response. 1.13. What is the ratio of the Imports(as % of merchandise exports) of Czech Republic in 2001 to that in 2004?
Make the answer very short. 0.98. What is the ratio of the Imports(as % of merchandise exports) of Comoros in 2001 to that in 2005?
Your answer should be compact. 1.07. What is the ratio of the Imports(as % of merchandise exports) in Cuba in 2001 to that in 2005?
Offer a very short reply. 1.15. What is the ratio of the Imports(as % of merchandise exports) of Czech Republic in 2001 to that in 2005?
Your response must be concise. 1.03. What is the ratio of the Imports(as % of merchandise exports) in French Polynesia in 2001 to that in 2005?
Provide a short and direct response. 0.99. What is the ratio of the Imports(as % of merchandise exports) in Comoros in 2001 to that in 2006?
Give a very brief answer. 0.86. What is the ratio of the Imports(as % of merchandise exports) of Cuba in 2001 to that in 2006?
Make the answer very short. 1.2. What is the ratio of the Imports(as % of merchandise exports) in Czech Republic in 2001 to that in 2006?
Ensure brevity in your answer.  1.03. What is the ratio of the Imports(as % of merchandise exports) of French Polynesia in 2001 to that in 2006?
Make the answer very short. 1.05. What is the ratio of the Imports(as % of merchandise exports) in Comoros in 2002 to that in 2003?
Offer a terse response. 0.99. What is the ratio of the Imports(as % of merchandise exports) of Cuba in 2002 to that in 2003?
Provide a short and direct response. 1.04. What is the ratio of the Imports(as % of merchandise exports) of Czech Republic in 2002 to that in 2003?
Your response must be concise. 0.93. What is the ratio of the Imports(as % of merchandise exports) of French Polynesia in 2002 to that in 2003?
Offer a terse response. 1. What is the ratio of the Imports(as % of merchandise exports) of Comoros in 2002 to that in 2004?
Your answer should be compact. 1.06. What is the ratio of the Imports(as % of merchandise exports) in Cuba in 2002 to that in 2004?
Provide a succinct answer. 1.07. What is the ratio of the Imports(as % of merchandise exports) in Czech Republic in 2002 to that in 2004?
Your response must be concise. 0.93. What is the ratio of the Imports(as % of merchandise exports) in French Polynesia in 2002 to that in 2004?
Your response must be concise. 1.08. What is the ratio of the Imports(as % of merchandise exports) of Comoros in 2002 to that in 2005?
Provide a short and direct response. 1.09. What is the ratio of the Imports(as % of merchandise exports) of Cuba in 2002 to that in 2005?
Offer a terse response. 1.09. What is the ratio of the Imports(as % of merchandise exports) of Czech Republic in 2002 to that in 2005?
Provide a succinct answer. 0.98. What is the ratio of the Imports(as % of merchandise exports) in French Polynesia in 2002 to that in 2005?
Your answer should be compact. 1.07. What is the ratio of the Imports(as % of merchandise exports) of Comoros in 2002 to that in 2006?
Provide a succinct answer. 0.88. What is the ratio of the Imports(as % of merchandise exports) of Cuba in 2002 to that in 2006?
Offer a terse response. 1.14. What is the ratio of the Imports(as % of merchandise exports) in Czech Republic in 2002 to that in 2006?
Give a very brief answer. 0.98. What is the ratio of the Imports(as % of merchandise exports) of French Polynesia in 2002 to that in 2006?
Provide a succinct answer. 1.14. What is the ratio of the Imports(as % of merchandise exports) of Comoros in 2003 to that in 2004?
Give a very brief answer. 1.07. What is the ratio of the Imports(as % of merchandise exports) of Cuba in 2003 to that in 2004?
Your response must be concise. 1.03. What is the ratio of the Imports(as % of merchandise exports) of French Polynesia in 2003 to that in 2004?
Give a very brief answer. 1.08. What is the ratio of the Imports(as % of merchandise exports) in Comoros in 2003 to that in 2005?
Offer a terse response. 1.1. What is the ratio of the Imports(as % of merchandise exports) in Cuba in 2003 to that in 2005?
Your response must be concise. 1.05. What is the ratio of the Imports(as % of merchandise exports) in Czech Republic in 2003 to that in 2005?
Your response must be concise. 1.05. What is the ratio of the Imports(as % of merchandise exports) of French Polynesia in 2003 to that in 2005?
Your answer should be very brief. 1.07. What is the ratio of the Imports(as % of merchandise exports) in Comoros in 2003 to that in 2006?
Give a very brief answer. 0.89. What is the ratio of the Imports(as % of merchandise exports) in Cuba in 2003 to that in 2006?
Your answer should be very brief. 1.09. What is the ratio of the Imports(as % of merchandise exports) of Czech Republic in 2003 to that in 2006?
Provide a short and direct response. 1.05. What is the ratio of the Imports(as % of merchandise exports) in French Polynesia in 2003 to that in 2006?
Provide a short and direct response. 1.14. What is the ratio of the Imports(as % of merchandise exports) in Comoros in 2004 to that in 2005?
Give a very brief answer. 1.03. What is the ratio of the Imports(as % of merchandise exports) in Cuba in 2004 to that in 2005?
Your answer should be compact. 1.02. What is the ratio of the Imports(as % of merchandise exports) of Czech Republic in 2004 to that in 2005?
Your answer should be compact. 1.05. What is the ratio of the Imports(as % of merchandise exports) of French Polynesia in 2004 to that in 2005?
Keep it short and to the point. 0.99. What is the ratio of the Imports(as % of merchandise exports) in Comoros in 2004 to that in 2006?
Your answer should be compact. 0.83. What is the ratio of the Imports(as % of merchandise exports) of Cuba in 2004 to that in 2006?
Keep it short and to the point. 1.06. What is the ratio of the Imports(as % of merchandise exports) of Czech Republic in 2004 to that in 2006?
Give a very brief answer. 1.05. What is the ratio of the Imports(as % of merchandise exports) of French Polynesia in 2004 to that in 2006?
Keep it short and to the point. 1.06. What is the ratio of the Imports(as % of merchandise exports) of Comoros in 2005 to that in 2006?
Ensure brevity in your answer.  0.8. What is the ratio of the Imports(as % of merchandise exports) of Cuba in 2005 to that in 2006?
Your answer should be very brief. 1.04. What is the ratio of the Imports(as % of merchandise exports) of Czech Republic in 2005 to that in 2006?
Offer a terse response. 1. What is the ratio of the Imports(as % of merchandise exports) of French Polynesia in 2005 to that in 2006?
Give a very brief answer. 1.06. What is the difference between the highest and the second highest Imports(as % of merchandise exports) of Comoros?
Your answer should be very brief. 7.42. What is the difference between the highest and the second highest Imports(as % of merchandise exports) in Cuba?
Keep it short and to the point. 2.93. What is the difference between the highest and the second highest Imports(as % of merchandise exports) of Czech Republic?
Give a very brief answer. 0.29. What is the difference between the highest and the second highest Imports(as % of merchandise exports) in French Polynesia?
Ensure brevity in your answer.  0.16. What is the difference between the highest and the lowest Imports(as % of merchandise exports) of Comoros?
Provide a short and direct response. 12.81. What is the difference between the highest and the lowest Imports(as % of merchandise exports) in Cuba?
Offer a terse response. 9.84. What is the difference between the highest and the lowest Imports(as % of merchandise exports) in Czech Republic?
Give a very brief answer. 5.71. What is the difference between the highest and the lowest Imports(as % of merchandise exports) in French Polynesia?
Give a very brief answer. 9.21. 